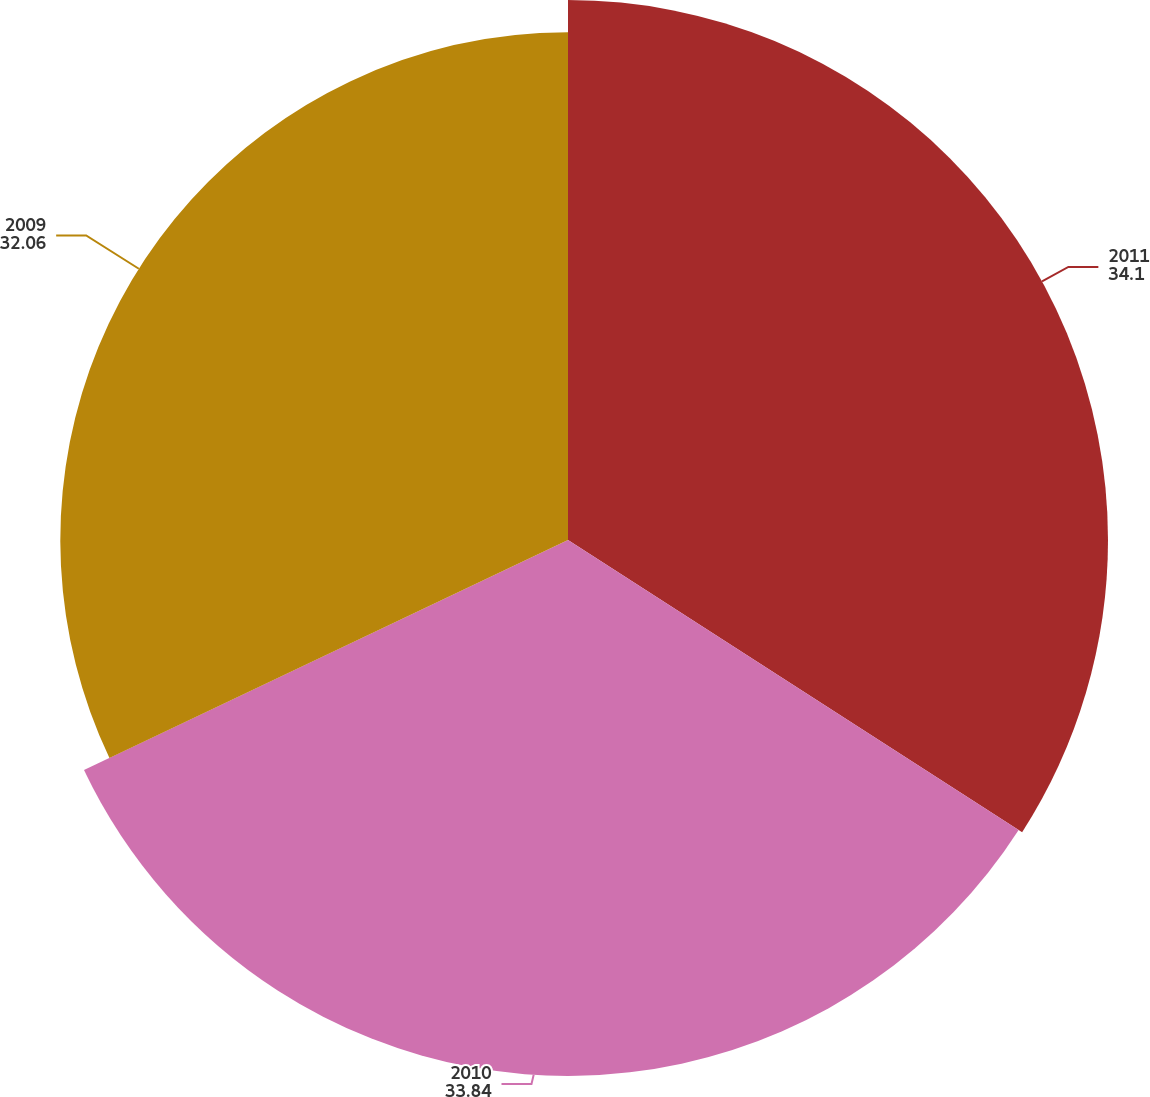Convert chart to OTSL. <chart><loc_0><loc_0><loc_500><loc_500><pie_chart><fcel>2011<fcel>2010<fcel>2009<nl><fcel>34.1%<fcel>33.84%<fcel>32.06%<nl></chart> 